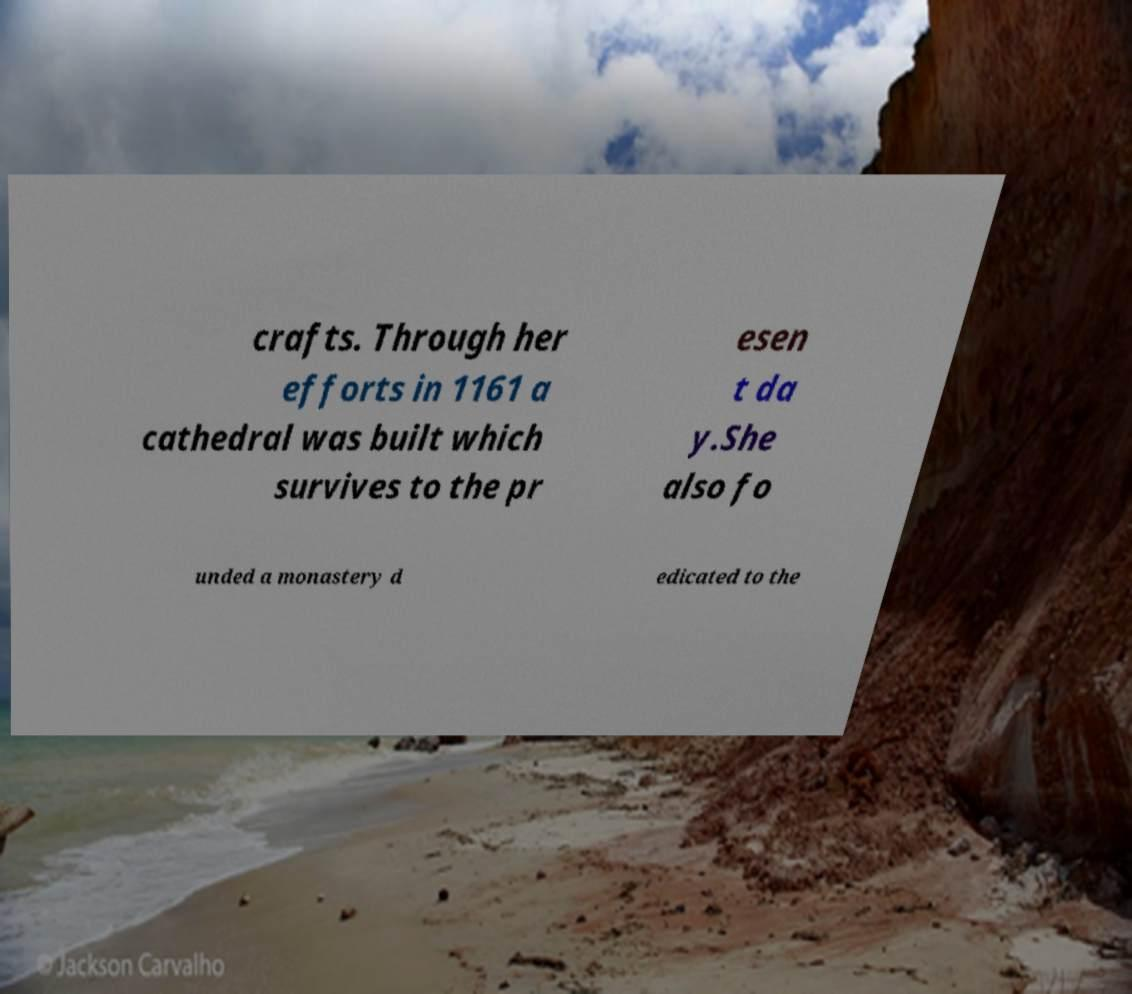What messages or text are displayed in this image? I need them in a readable, typed format. crafts. Through her efforts in 1161 a cathedral was built which survives to the pr esen t da y.She also fo unded a monastery d edicated to the 